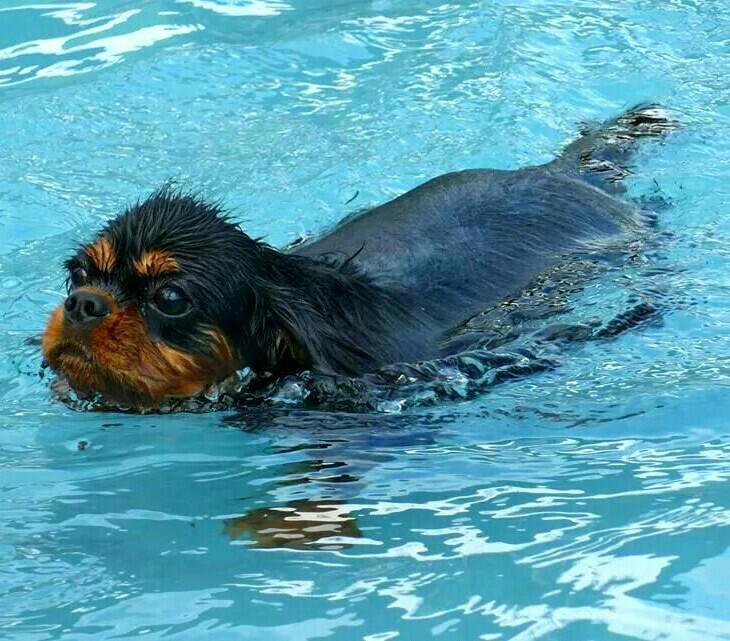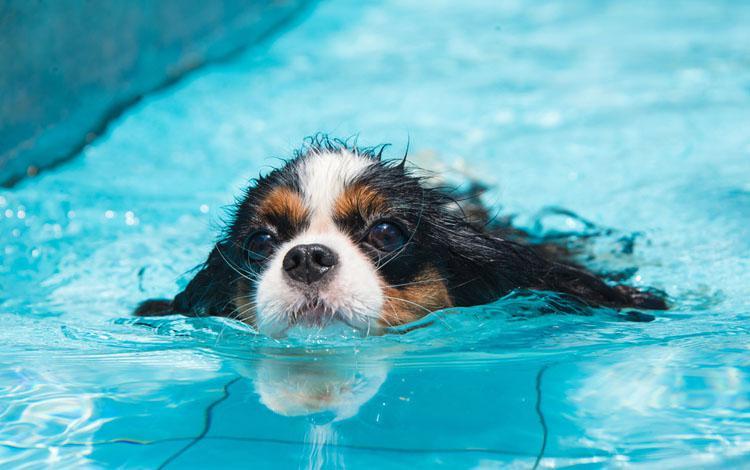The first image is the image on the left, the second image is the image on the right. For the images displayed, is the sentence "Left image shows a dog swimming leftward." factually correct? Answer yes or no. Yes. 